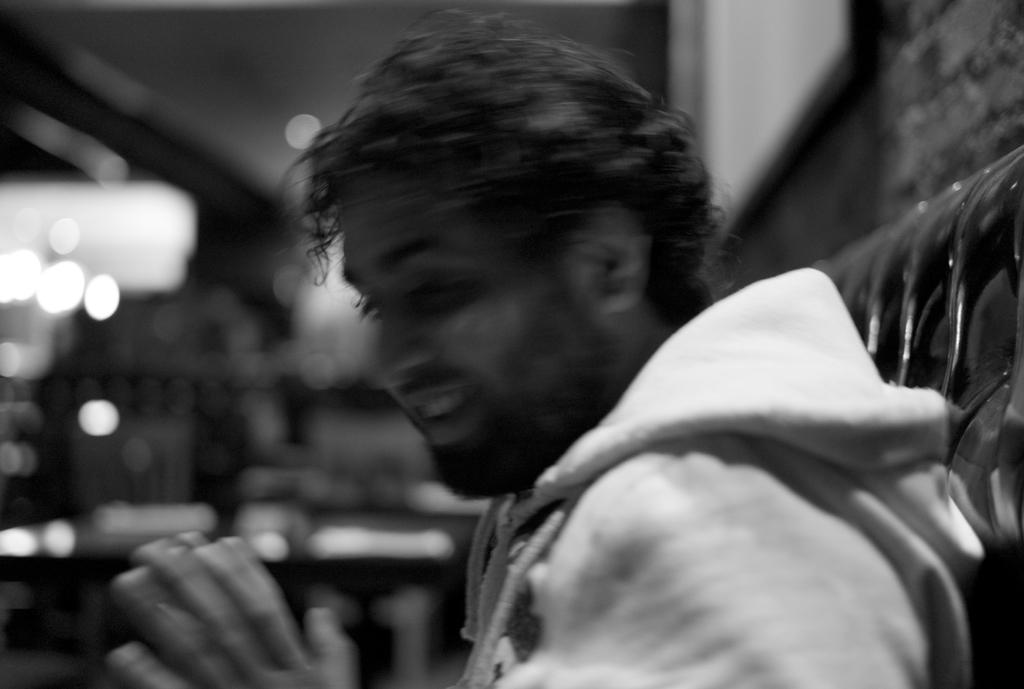Who is present in the image? There is a man in the image. What is the man's facial expression? The man is smiling. What can be seen in the background of the image? There are lights and some objects in the background of the image. How would you describe the background? The background is blurry. How many cars can be seen in the image? There are no cars present in the image. What type of coil is being used by the man in the image? There is no coil present in the image. 